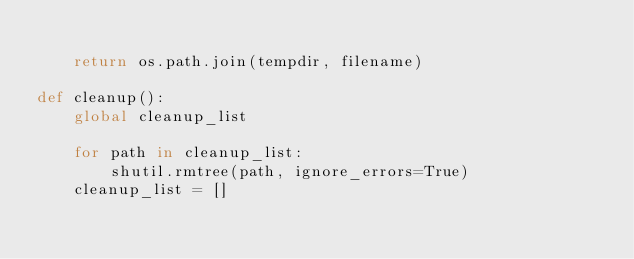Convert code to text. <code><loc_0><loc_0><loc_500><loc_500><_Python_>    
    return os.path.join(tempdir, filename)

def cleanup():
    global cleanup_list

    for path in cleanup_list:
        shutil.rmtree(path, ignore_errors=True)
    cleanup_list = []
</code> 